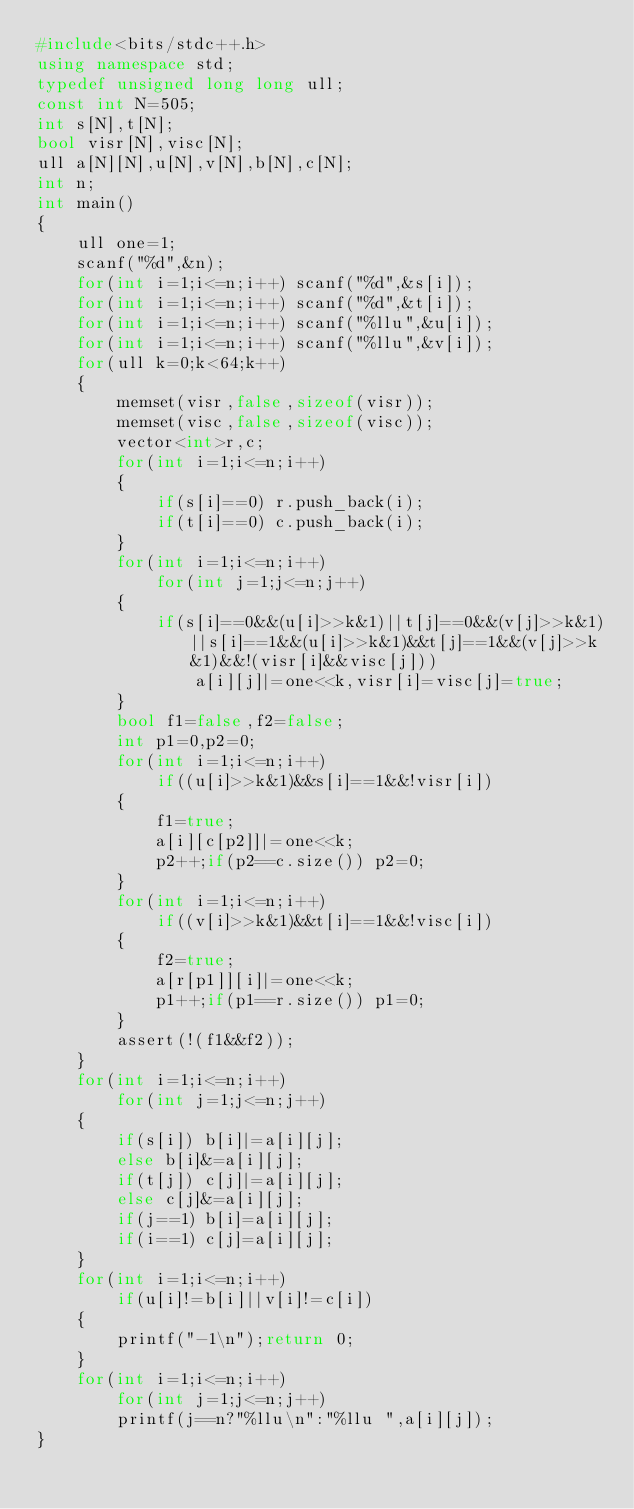<code> <loc_0><loc_0><loc_500><loc_500><_C++_>#include<bits/stdc++.h>
using namespace std;
typedef unsigned long long ull;
const int N=505;
int s[N],t[N];
bool visr[N],visc[N];
ull a[N][N],u[N],v[N],b[N],c[N];
int n;
int main()
{
    ull one=1;
    scanf("%d",&n);
    for(int i=1;i<=n;i++) scanf("%d",&s[i]);
    for(int i=1;i<=n;i++) scanf("%d",&t[i]);
    for(int i=1;i<=n;i++) scanf("%llu",&u[i]);
    for(int i=1;i<=n;i++) scanf("%llu",&v[i]);
    for(ull k=0;k<64;k++)
    {
        memset(visr,false,sizeof(visr));
        memset(visc,false,sizeof(visc));
        vector<int>r,c;
        for(int i=1;i<=n;i++)
        {
            if(s[i]==0) r.push_back(i);
            if(t[i]==0) c.push_back(i);
        }
        for(int i=1;i<=n;i++)
            for(int j=1;j<=n;j++)
        {
            if(s[i]==0&&(u[i]>>k&1)||t[j]==0&&(v[j]>>k&1)||s[i]==1&&(u[i]>>k&1)&&t[j]==1&&(v[j]>>k&1)&&!(visr[i]&&visc[j]))
                a[i][j]|=one<<k,visr[i]=visc[j]=true;
        }
        bool f1=false,f2=false;
        int p1=0,p2=0;
        for(int i=1;i<=n;i++)
            if((u[i]>>k&1)&&s[i]==1&&!visr[i])
        {
            f1=true;
            a[i][c[p2]]|=one<<k;
            p2++;if(p2==c.size()) p2=0;
        }
        for(int i=1;i<=n;i++)
            if((v[i]>>k&1)&&t[i]==1&&!visc[i])
        {
            f2=true;
            a[r[p1]][i]|=one<<k;
            p1++;if(p1==r.size()) p1=0;
        }
        assert(!(f1&&f2));
    }
    for(int i=1;i<=n;i++)
        for(int j=1;j<=n;j++)
    {
        if(s[i]) b[i]|=a[i][j];
        else b[i]&=a[i][j];
        if(t[j]) c[j]|=a[i][j];
        else c[j]&=a[i][j];
        if(j==1) b[i]=a[i][j];
        if(i==1) c[j]=a[i][j];
    }
    for(int i=1;i<=n;i++)
        if(u[i]!=b[i]||v[i]!=c[i])
    {
        printf("-1\n");return 0;
    }
    for(int i=1;i<=n;i++)
        for(int j=1;j<=n;j++)
        printf(j==n?"%llu\n":"%llu ",a[i][j]);
}
</code> 